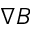<formula> <loc_0><loc_0><loc_500><loc_500>\nabla B</formula> 